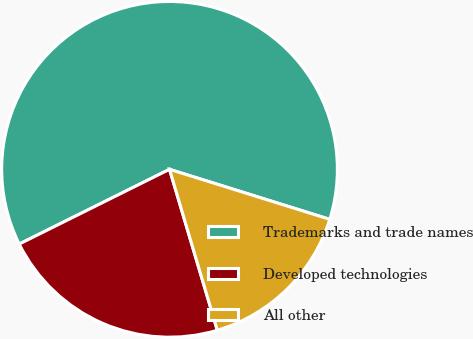Convert chart to OTSL. <chart><loc_0><loc_0><loc_500><loc_500><pie_chart><fcel>Trademarks and trade names<fcel>Developed technologies<fcel>All other<nl><fcel>62.16%<fcel>22.25%<fcel>15.59%<nl></chart> 